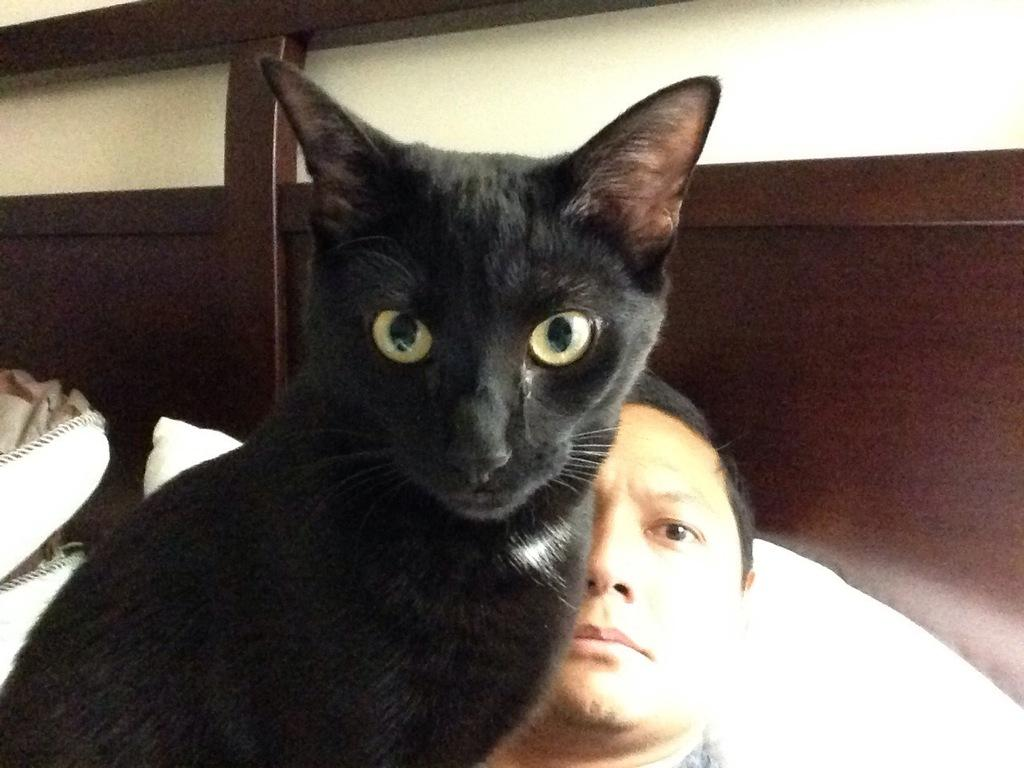What type of animal is in the image? There is a black color cat in the image. Who else is present in the image? There is a man in the image. Where is the library located in the image? There is no library present in the image. What type of root can be seen growing from the cat's paw in the image? There is no root present in the image, and the cat's paw is not shown. 